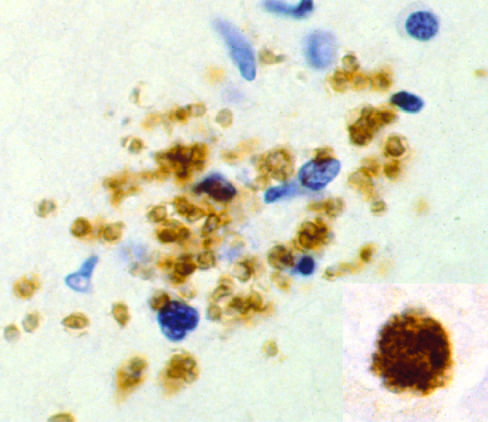re hours demonstrated by immunohistochemical staining?
Answer the question using a single word or phrase. No 